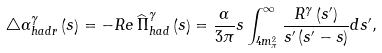Convert formula to latex. <formula><loc_0><loc_0><loc_500><loc_500>\bigtriangleup \alpha _ { h a d r } ^ { \gamma } \left ( s \right ) = - R e \widehat { \, \Pi } _ { h a d } ^ { \gamma } \left ( s \right ) = \frac { \alpha } { 3 \pi } s \int _ { 4 m _ { \pi } ^ { 2 } } ^ { \infty } \frac { R ^ { \gamma } \left ( s ^ { \prime } \right ) } { s ^ { \prime } \left ( s ^ { \prime } - s \right ) } d s ^ { \prime } ,</formula> 